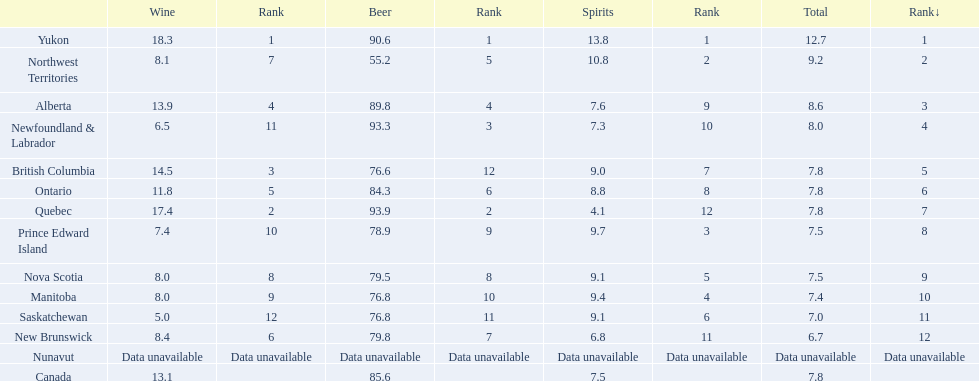Which country ranks #1 in alcoholic beverage consumption? Yukon. Of that country, how many total liters of spirits do they consume? 12.7. 